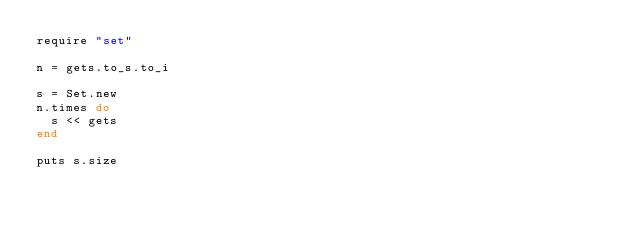<code> <loc_0><loc_0><loc_500><loc_500><_Ruby_>require "set"

n = gets.to_s.to_i

s = Set.new
n.times do
  s << gets
end

puts s.size</code> 